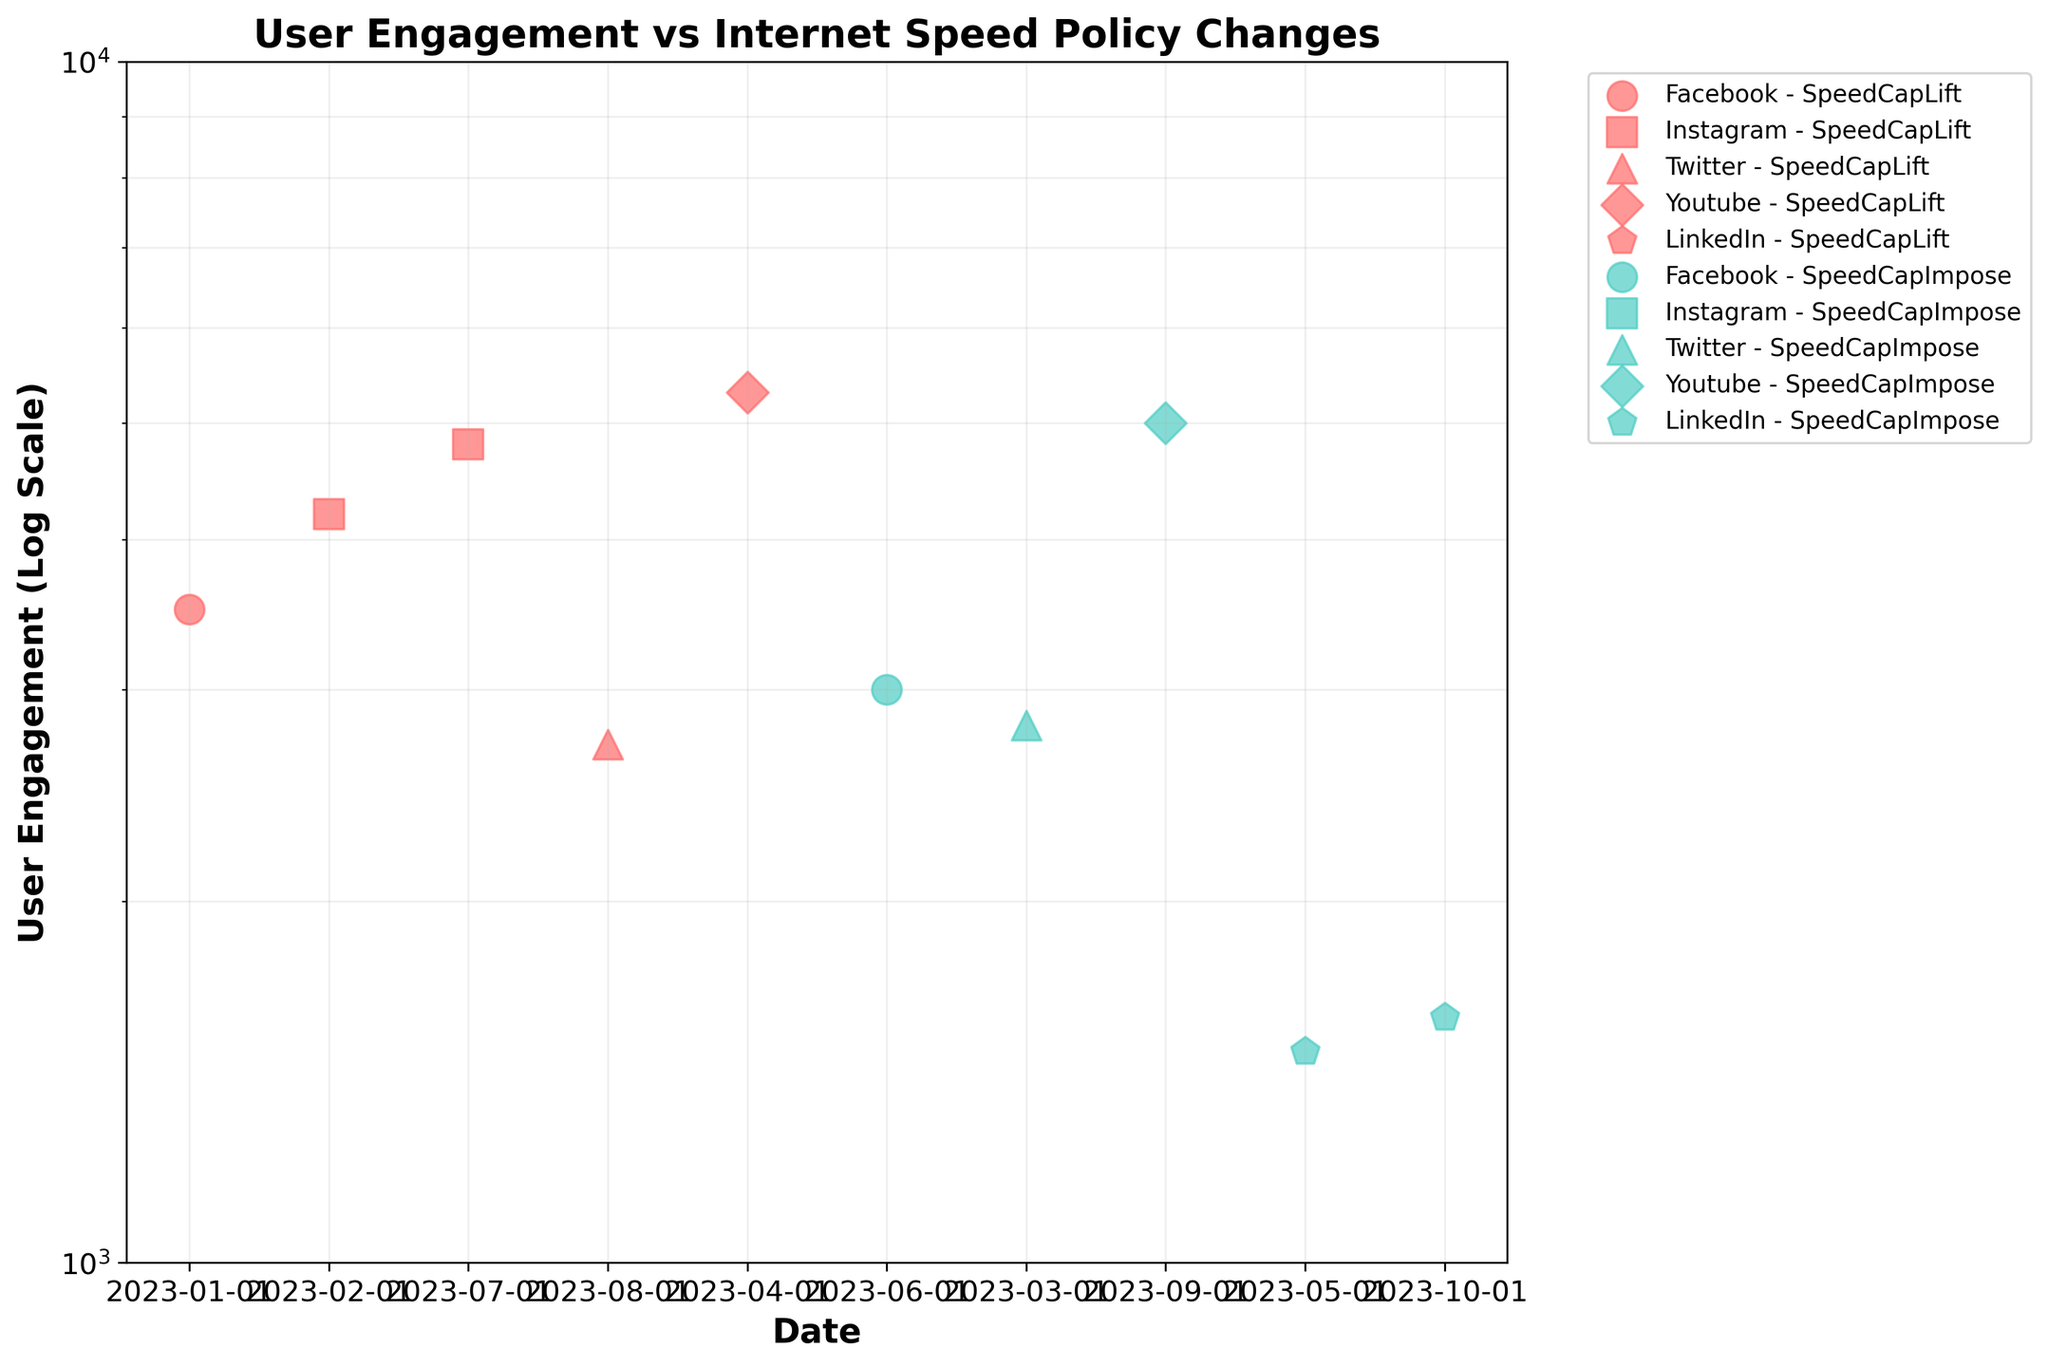What is the title of the figure? The title is typically located at the top of the figure and summarizing the main theme of the plot indicates "User Engagement vs Internet Speed Policy Changes".
Answer: User Engagement vs Internet Speed Policy Changes How many social media platforms are represented in the figure? Looking at the different types of markers used in the scatter plot, each representing a unique platform. There are five different marker types visible.
Answer: 5 Which color represents 'SpeedCapImpose' in the plot? By observing the legend and the colors used in the scatter plot, the color associated with 'SpeedCapImpose' is a blue-green shade.
Answer: Blue-green What is the engagement value for Instagram on February 1, 2023? Locate the Instagram marker on the date February 1, 2023, and check its position on the y-axis to determine the user engagement value.
Answer: 4200 Are there more 'SpeedCapLift' or 'SpeedCapImpose' policy changes in the dataset? Examine the plot to count the number of points with red (SpeedCapLift) and blue-green (SpeedCapImpose) colors. There are five instances of 'SpeedCapLift' and five of 'SpeedCapImpose'.
Answer: Equal Which ISP had the highest user engagement for Facebook? Find the markers for Facebook (circles) and identify the highest y-axis value corresponding to the correct color; the highest is for Comcast.
Answer: Comcast What is the average engagement value for 'SpeedCapLift' policies? Sum all the engagement values for 'SpeedCapLift' and divide by the number of such instances: (3500 + 4200 + 5300 + 4800 + 2700) / 5 = 20500 / 5 = 4100.
Answer: 4100 How does the engagement for Twitter change with different internet speed policies? Compare the engagement values for Twitter for both 'SpeedCapLift' and 'SpeedCapImpose'; both have values around 2700 and 2800 respectively.
Answer: Slightly higher with 'SpeedCapLift' Which platform has the lowest engagement for 'SpeedCapImpose' policies? Identify the platform markers for 'SpeedCapImpose' and check the lowest y-axis value; LinkedIn at 1500.
Answer: LinkedIn 